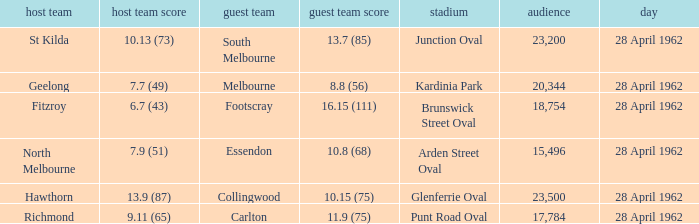At what venue did an away team score 10.15 (75)? Glenferrie Oval. 